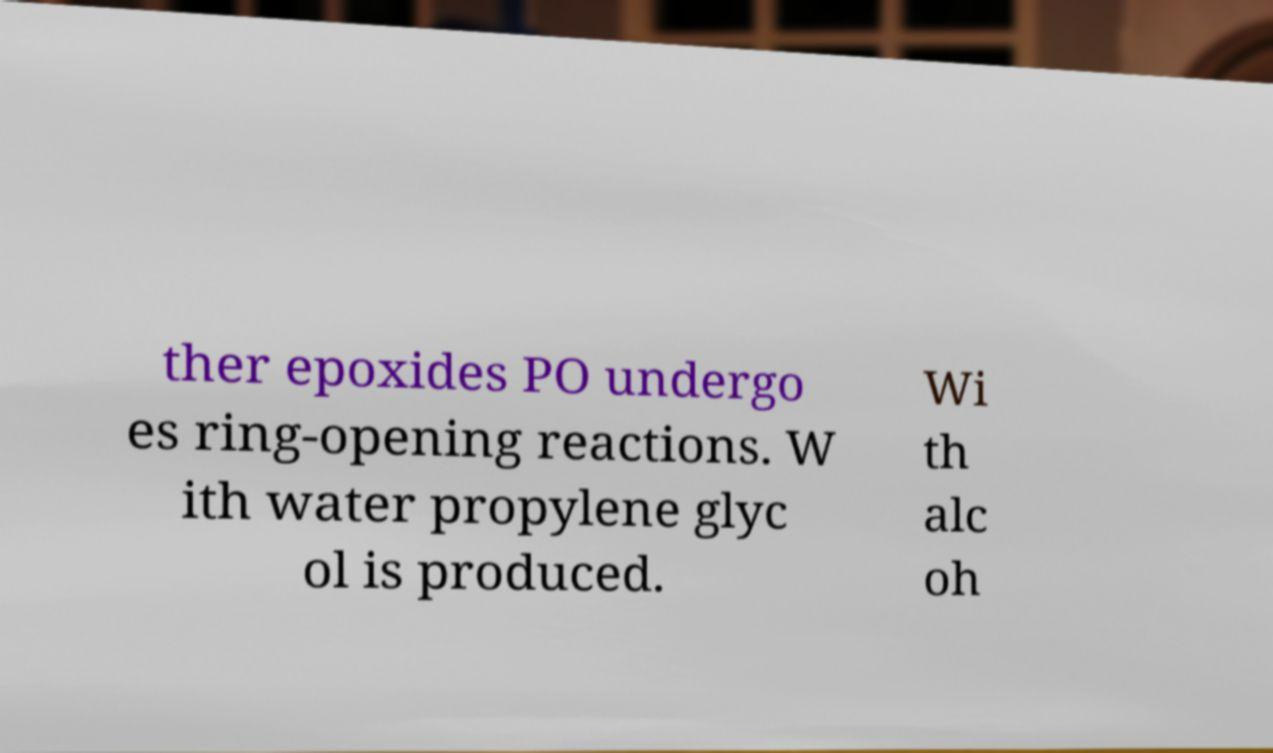I need the written content from this picture converted into text. Can you do that? ther epoxides PO undergo es ring-opening reactions. W ith water propylene glyc ol is produced. Wi th alc oh 